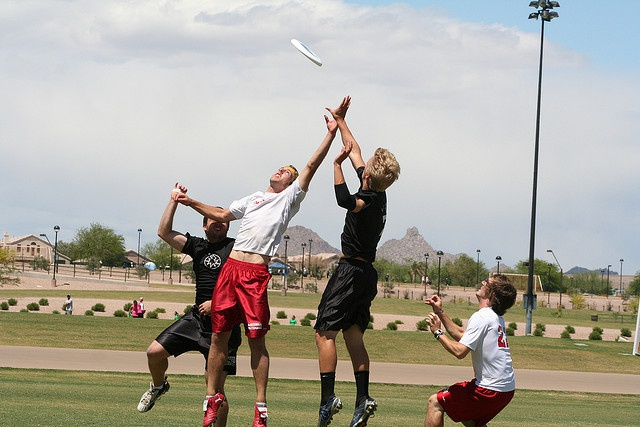Describe the objects in this image and their specific colors. I can see people in lightgray, black, gainsboro, gray, and maroon tones, people in lightgray, white, black, maroon, and brown tones, people in lightgray, black, lavender, gray, and tan tones, people in lightgray, black, maroon, gray, and tan tones, and frisbee in lightgray, white, darkgray, and gray tones in this image. 